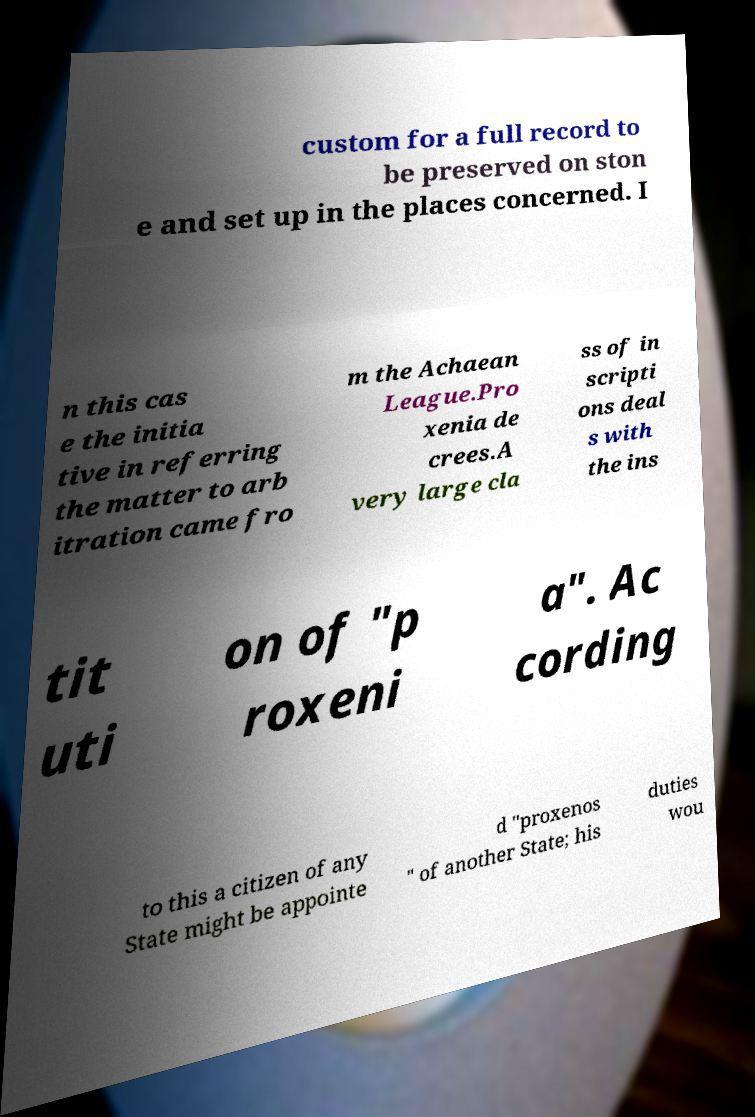Could you assist in decoding the text presented in this image and type it out clearly? custom for a full record to be preserved on ston e and set up in the places concerned. I n this cas e the initia tive in referring the matter to arb itration came fro m the Achaean League.Pro xenia de crees.A very large cla ss of in scripti ons deal s with the ins tit uti on of "p roxeni a". Ac cording to this a citizen of any State might be appointe d "proxenos " of another State; his duties wou 